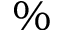<formula> <loc_0><loc_0><loc_500><loc_500>\%</formula> 